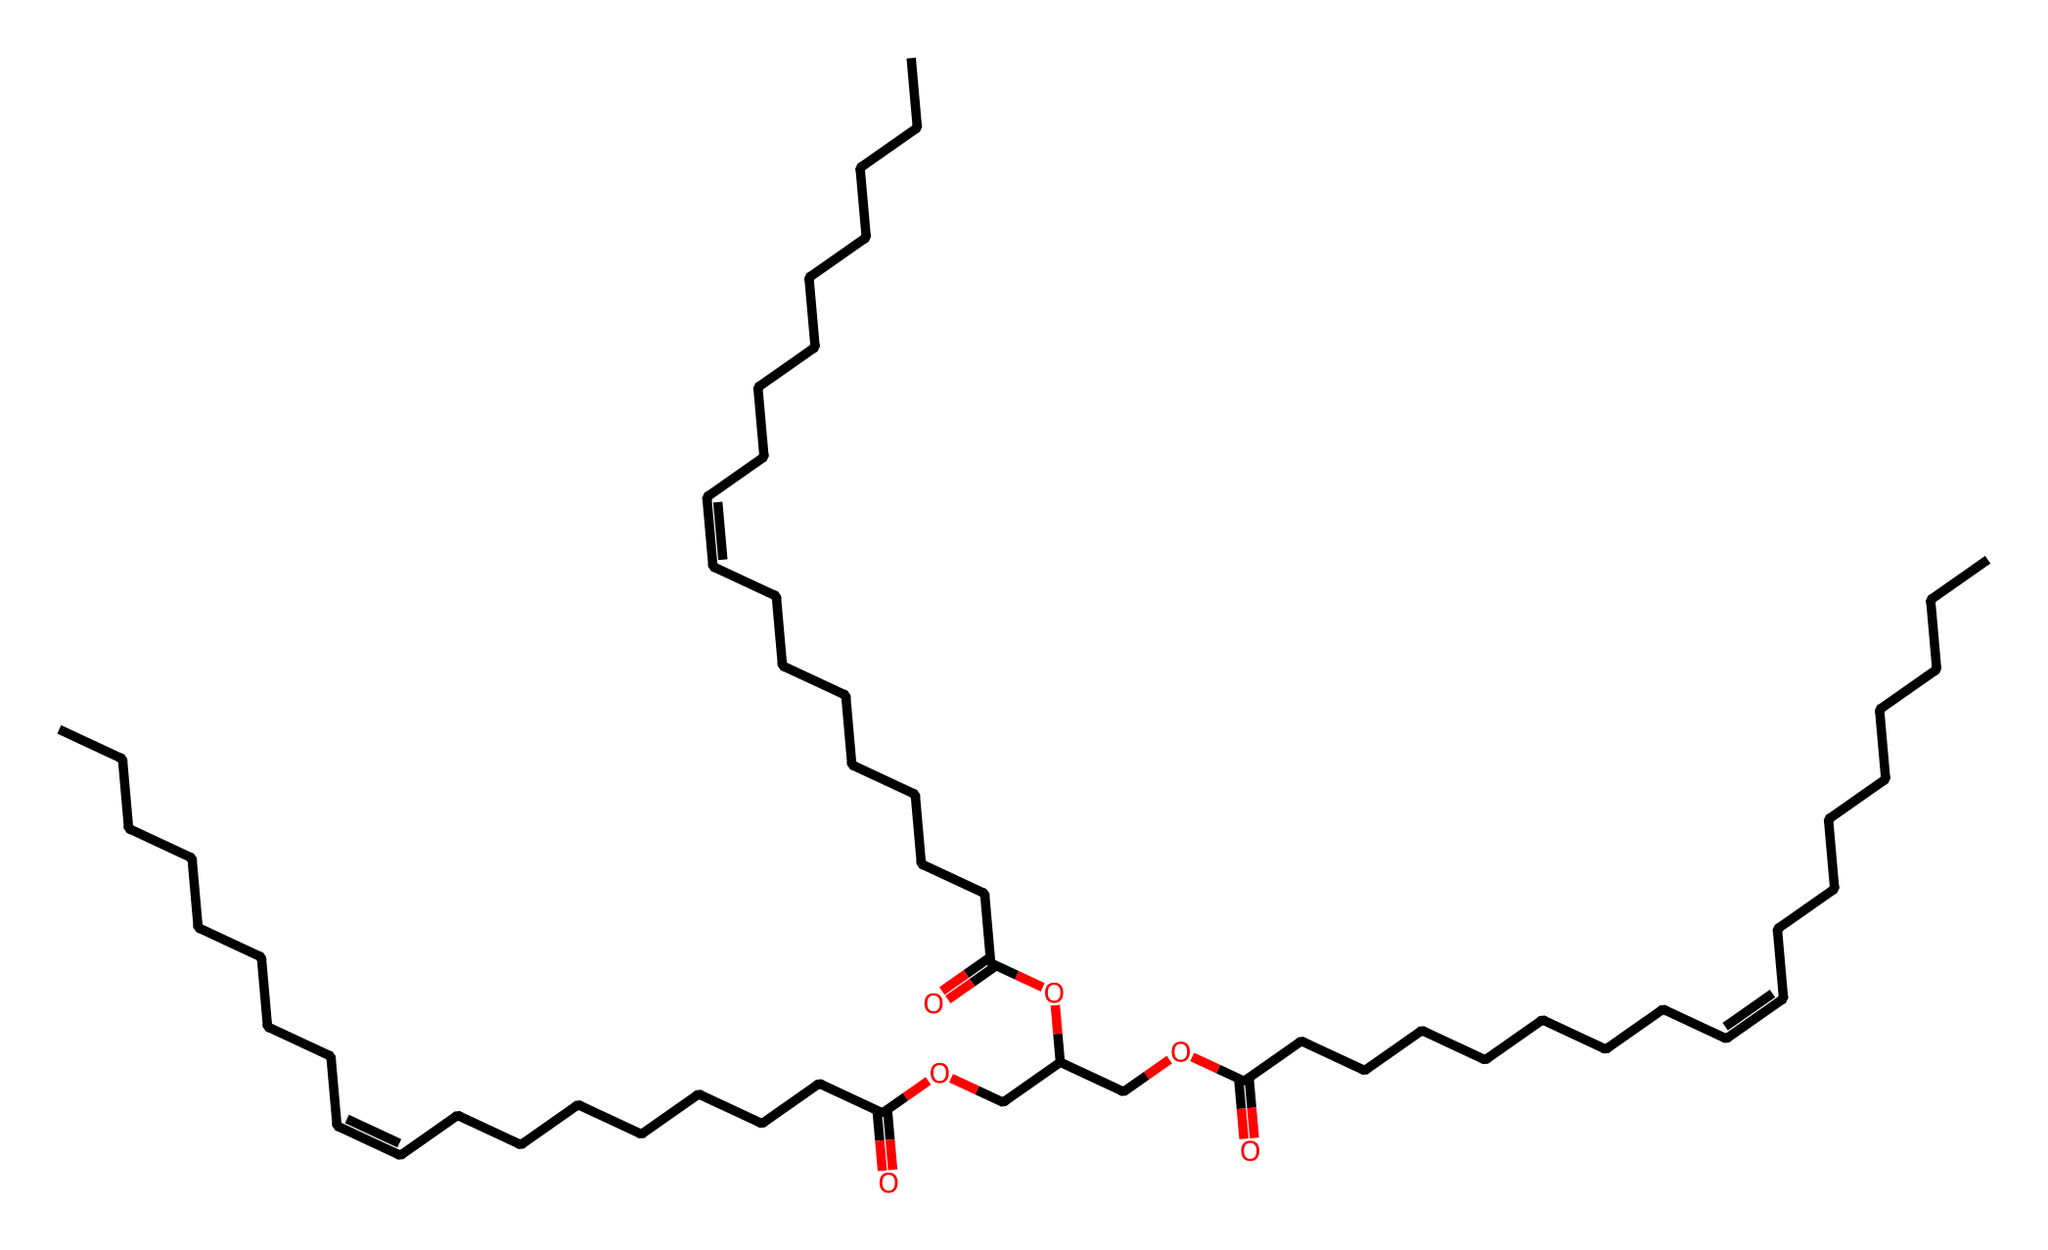What type of fatty acids are present in linseed oil? Linseed oil contains unsaturated fatty acids, which can be recognized by the presence of double bonds in the molecule. The SMILES representation reveals alkenes due to the "/C=C\" notation, indicating there's at least one site with unsaturation.
Answer: unsaturated fatty acids How many carbon atoms are in linseed oil? To determine the number of carbon atoms, count the occurrences of 'C' in the SMILES notation. Each 'C' signifies a carbon atom, and upon counting, there are 48 carbon representations in the chain.
Answer: 48 What functional group is indicated by "C(=O)O" in linseed oil? The "C(=O)O" indicates a carboxylic acid functional group, where 'C(=O)' specifies the carbonyl part and the 'O' attached indicates the hydroxyl part. This confirms the presence of a carboxylic acid in the structure.
Answer: carboxylic acid What is the general use of linseed oil in oil paints? Linseed oil is primarily used as a binder in oil paints, providing adhesion and gloss to the paint film. The presence of unsaturated fatty acids allows it to dry to a hard film, making it suitable for painting.
Answer: binder Which part of the chemical structure contributes to the drying property of linseed oil? The drying property of linseed oil is attributed to the unsaturated fatty acids, specifically the double bonds within the fatty acid chains. The presence of double bonds allows for oxidative polymerization upon exposure to air, leading to drying.
Answer: unsaturated fatty acids 